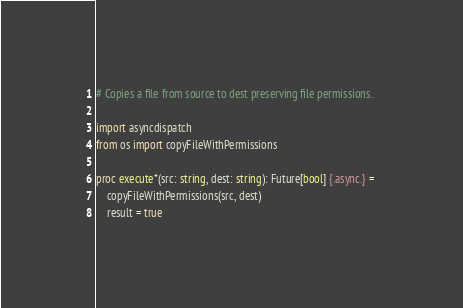<code> <loc_0><loc_0><loc_500><loc_500><_Nim_># Copies a file from source to dest preserving file permissions.

import asyncdispatch
from os import copyFileWithPermissions

proc execute*(src: string, dest: string): Future[bool] {.async.} = 
    copyFileWithPermissions(src, dest)
    result = true
</code> 